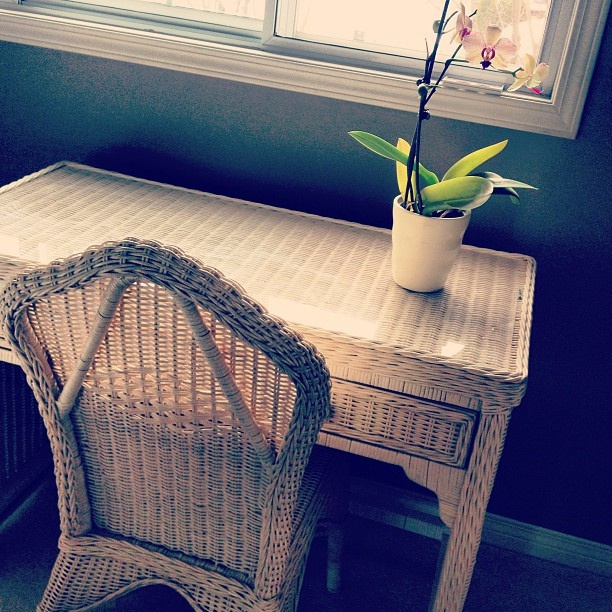Describe the objects in this image and their specific colors. I can see chair in darkgray, gray, and navy tones, dining table in darkgray, tan, and gray tones, potted plant in darkgray and tan tones, and vase in darkgray, tan, and gray tones in this image. 